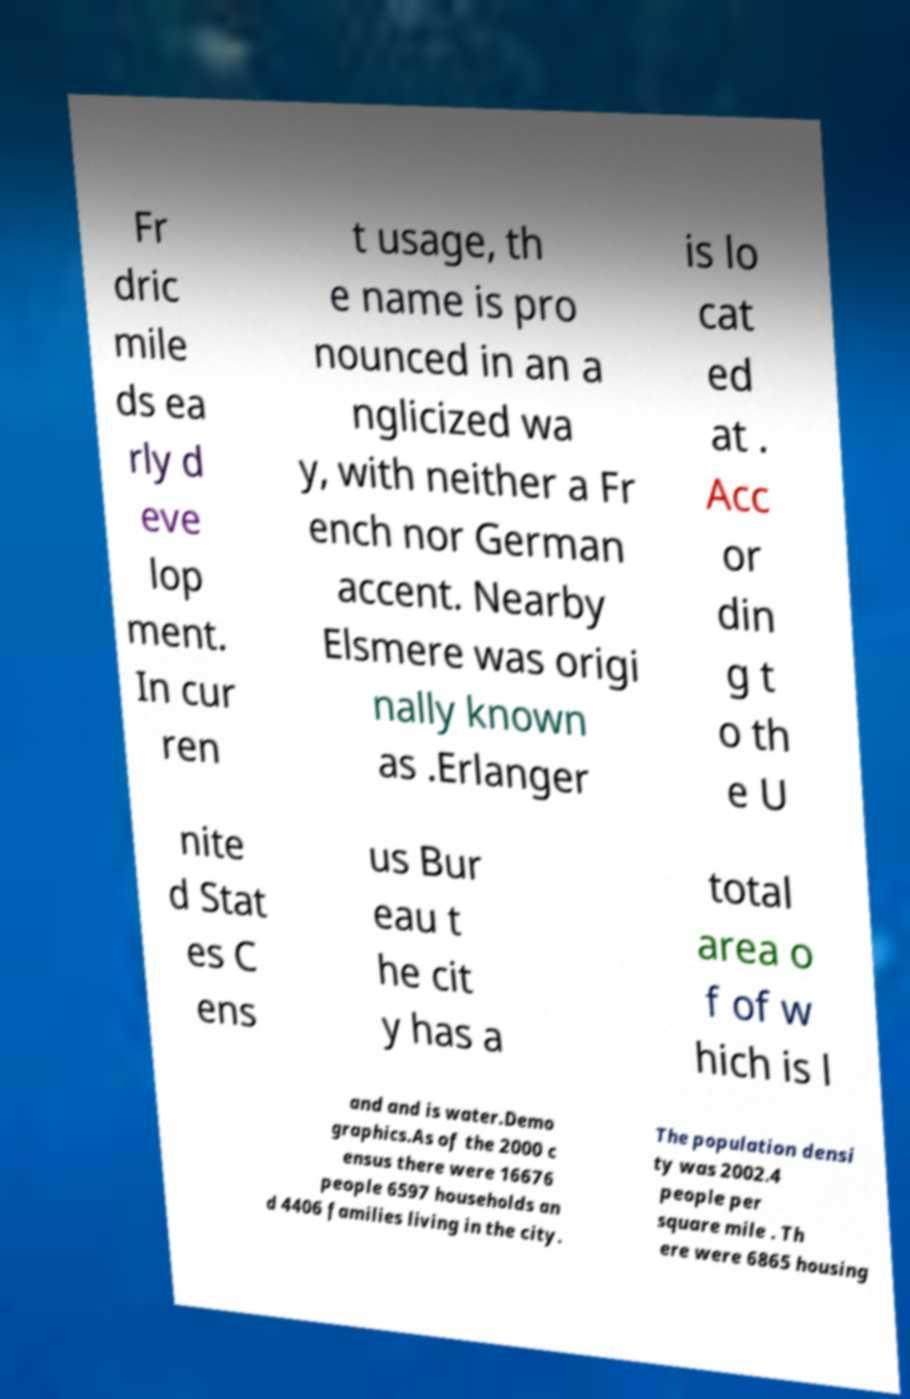Could you extract and type out the text from this image? Fr dric mile ds ea rly d eve lop ment. In cur ren t usage, th e name is pro nounced in an a nglicized wa y, with neither a Fr ench nor German accent. Nearby Elsmere was origi nally known as .Erlanger is lo cat ed at . Acc or din g t o th e U nite d Stat es C ens us Bur eau t he cit y has a total area o f of w hich is l and and is water.Demo graphics.As of the 2000 c ensus there were 16676 people 6597 households an d 4406 families living in the city. The population densi ty was 2002.4 people per square mile . Th ere were 6865 housing 